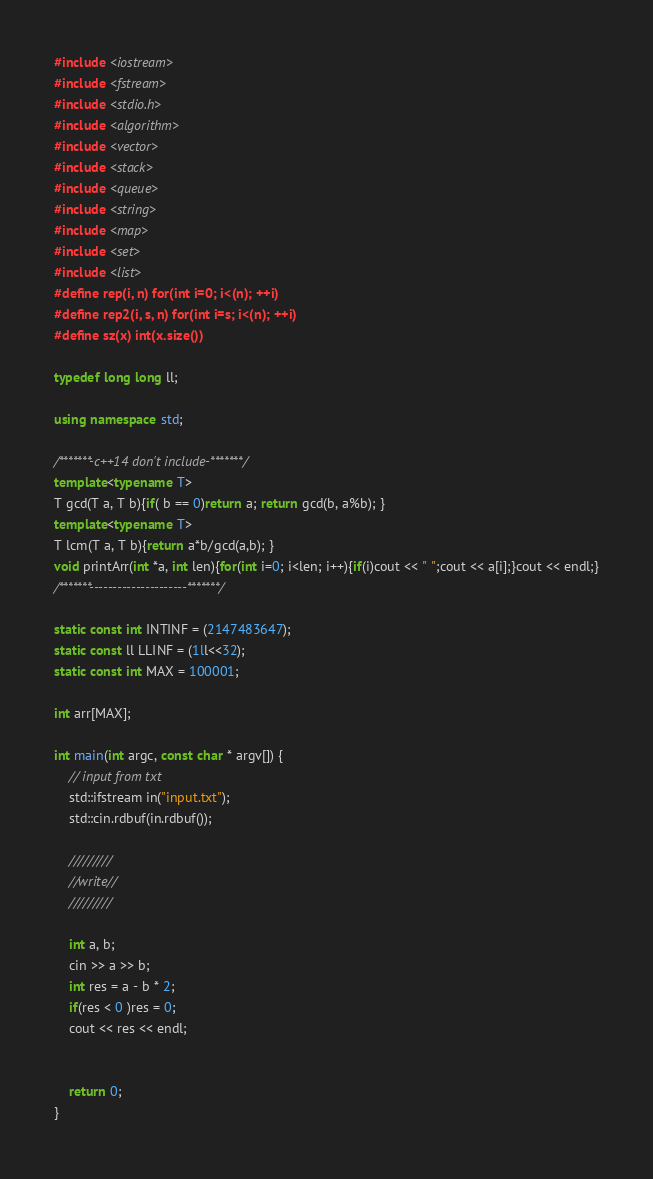<code> <loc_0><loc_0><loc_500><loc_500><_C++_>#include <iostream>
#include <fstream>
#include <stdio.h>
#include <algorithm>
#include <vector>
#include <stack>
#include <queue>
#include <string>
#include <map>
#include <set>
#include <list>
#define rep(i, n) for(int i=0; i<(n); ++i)
#define rep2(i, s, n) for(int i=s; i<(n); ++i)
#define sz(x) int(x.size())

typedef long long ll;

using namespace std;

/*******-c++14 don't include-*******/
template<typename T>
T gcd(T a, T b){if( b == 0)return a; return gcd(b, a%b); }
template<typename T>
T lcm(T a, T b){return a*b/gcd(a,b); }
void printArr(int *a, int len){for(int i=0; i<len; i++){if(i)cout << " ";cout << a[i];}cout << endl;}
/*******---------------------*******/

static const int INTINF = (2147483647);
static const ll LLINF = (1ll<<32);
static const int MAX = 100001;

int arr[MAX];

int main(int argc, const char * argv[]) {
    // input from txt
    std::ifstream in("input.txt");
    std::cin.rdbuf(in.rdbuf());
    
    /////////
    //write//
    /////////
    
    int a, b;
    cin >> a >> b;
    int res = a - b * 2;
    if(res < 0 )res = 0;
    cout << res << endl;
    
    
    return 0;
}
</code> 